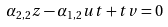Convert formula to latex. <formula><loc_0><loc_0><loc_500><loc_500>\alpha _ { 2 , 2 } z - \alpha _ { 1 , 2 } u t + t v = 0</formula> 